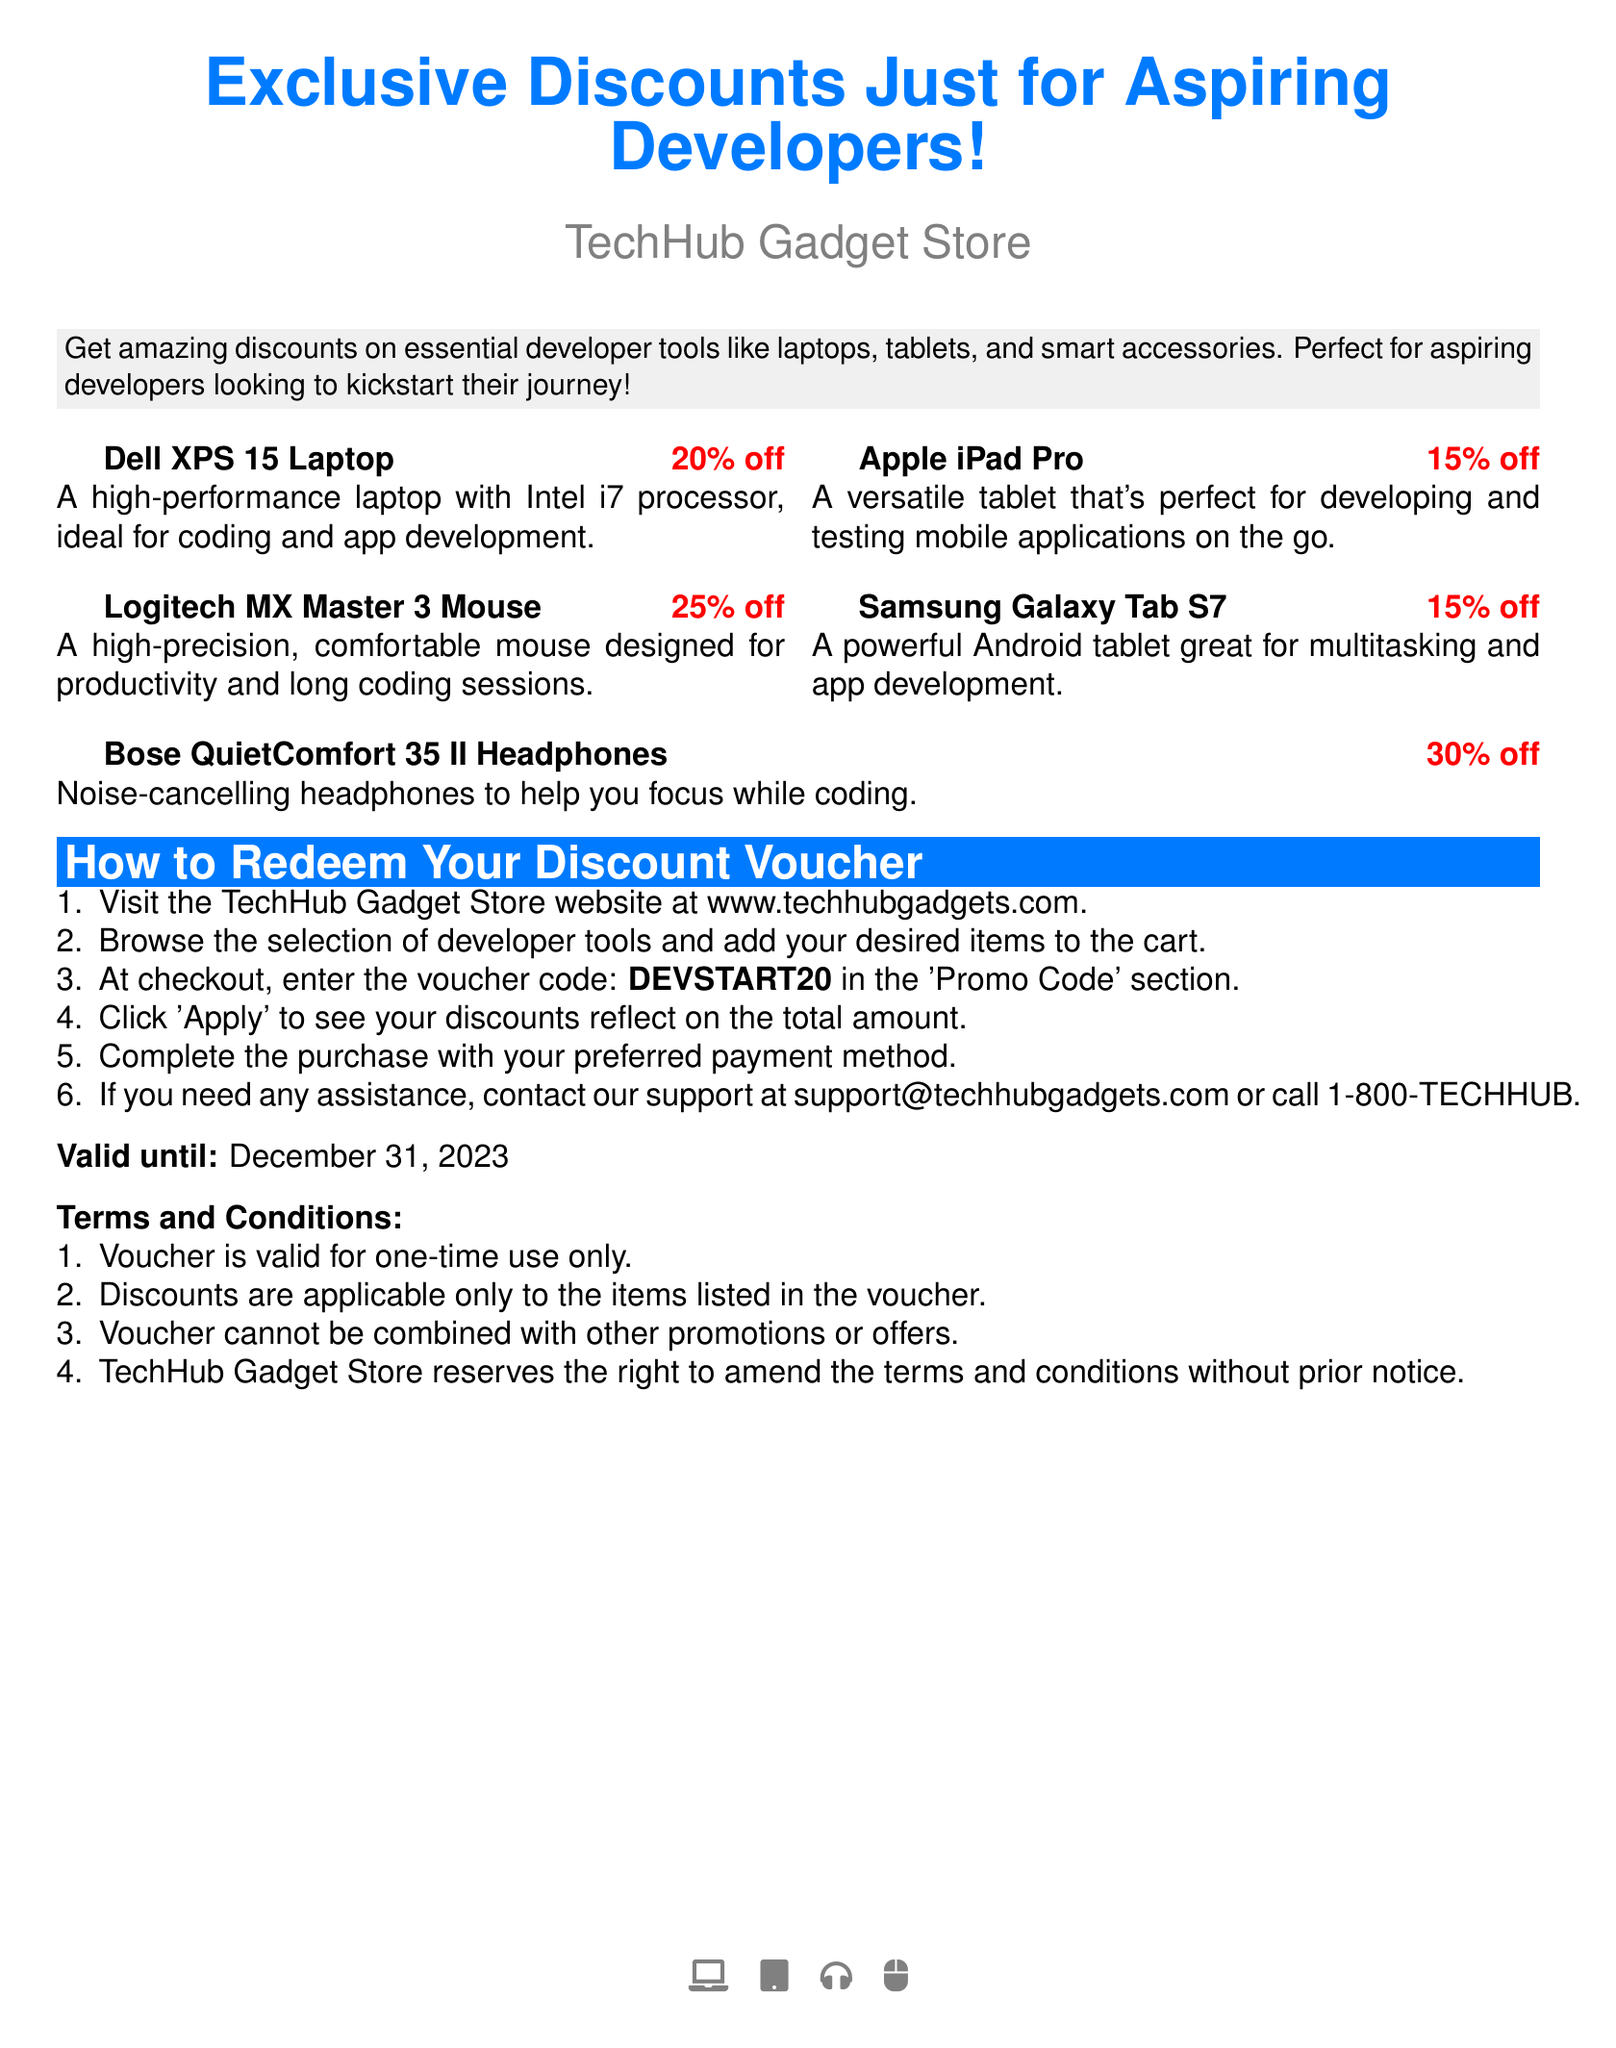What is the name of the store? The document explicitly states that the store is called TechHub Gadget Store.
Answer: TechHub Gadget Store What is the discount for the Dell XPS 15 Laptop? The document mentions that the Dell XPS 15 Laptop has a discount of 20 percent.
Answer: 20% off What is the voucher code to apply at checkout? The document specifies the voucher code to enter in the 'Promo Code' section during checkout.
Answer: DEVSTART20 What type of headphones are on offer? The document lists Bose QuietComfort 35 II, which are noise-cancelling headphones, as part of the offer.
Answer: Bose QuietComfort 35 II How can you contact support? The document provides an email and phone number to reach support for assistance.
Answer: support@techhubgadgets.com What is the validity period of the voucher? The document states the voucher is valid until a specific date, which is included in the text.
Answer: December 31, 2023 What percentage discount is offered for the Logitech MX Master 3 Mouse? The document indicates the discount percentage for this specific mouse.
Answer: 25% off What is the main purpose of the voucher? The document highlights that the voucher is designed for aspiring developers seeking tools for their journey.
Answer: Discounts on essential developer tools Are multiple promotions allowed with this voucher? The document specifies a rule regarding the use of promotions in conjunction with the voucher.
Answer: No 